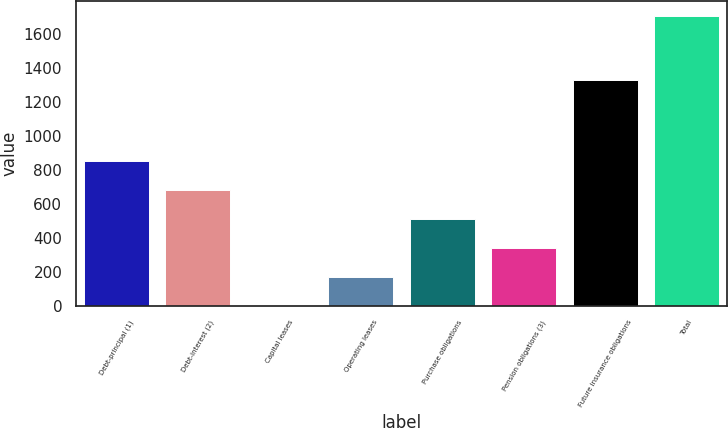Convert chart. <chart><loc_0><loc_0><loc_500><loc_500><bar_chart><fcel>Debt-principal (1)<fcel>Debt-interest (2)<fcel>Capital leases<fcel>Operating leases<fcel>Purchase obligations<fcel>Pension obligations (3)<fcel>Future insurance obligations<fcel>Total<nl><fcel>854.34<fcel>684<fcel>2.64<fcel>172.98<fcel>513.66<fcel>343.32<fcel>1326<fcel>1706<nl></chart> 